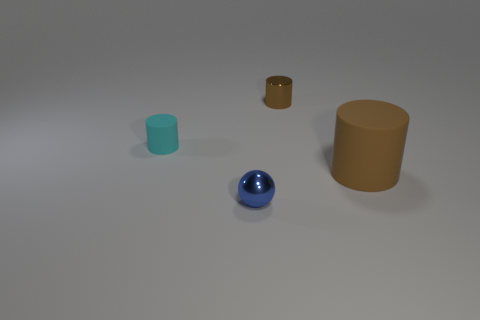How many tiny cyan rubber objects are left of the blue metal sphere?
Make the answer very short. 1. How big is the cylinder on the left side of the brown cylinder on the left side of the cylinder in front of the cyan thing?
Offer a very short reply. Small. Is there a rubber thing that is on the right side of the brown object that is to the left of the rubber thing that is on the right side of the small metal cylinder?
Keep it short and to the point. Yes. Are there more brown cylinders than small blue shiny objects?
Provide a short and direct response. Yes. What color is the rubber object that is to the right of the small brown cylinder?
Provide a short and direct response. Brown. Is the number of rubber cylinders that are to the left of the blue object greater than the number of purple matte cylinders?
Your response must be concise. Yes. Does the tiny brown object have the same material as the big brown object?
Ensure brevity in your answer.  No. How many other objects are the same shape as the small brown shiny object?
Offer a terse response. 2. There is a small metal ball that is on the left side of the matte cylinder on the right side of the tiny shiny object that is in front of the tiny cyan rubber thing; what is its color?
Make the answer very short. Blue. Does the brown object behind the large matte cylinder have the same shape as the small cyan thing?
Provide a succinct answer. Yes. 